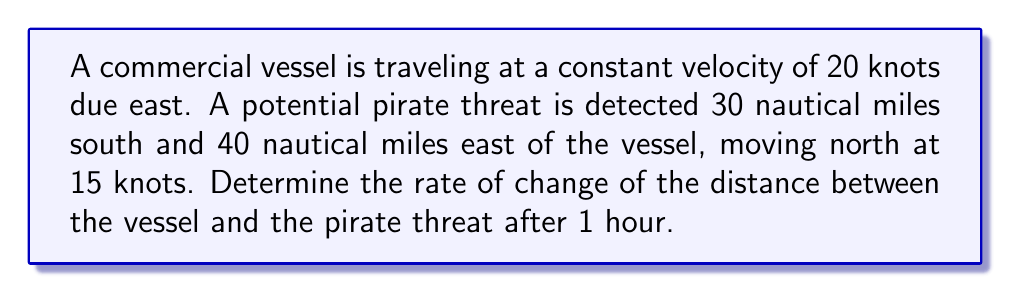Show me your answer to this math problem. Let's approach this step-by-step:

1) First, we need to set up a coordinate system. Let's place the origin at the initial position of the commercial vessel.

2) The vessel's position after time $t$ (in hours) is:
   $$(20t, 0)$$

3) The pirate's initial position is (40, -30). After time $t$, its position is:
   $$(40, -30 + 15t)$$

4) The distance $d$ between the two vessels at time $t$ is given by:
   $$d(t) = \sqrt{(40-20t)^2 + (-30+15t)^2}$$

5) To find the rate of change of distance, we need to differentiate $d(t)$ with respect to $t$:
   $$\frac{d}{dt}d(t) = \frac{1}{2}((40-20t)^2 + (-30+15t)^2)^{-1/2} \cdot \frac{d}{dt}((40-20t)^2 + (-30+15t)^2)$$

6) Simplifying:
   $$\frac{d}{dt}d(t) = \frac{-40(40-20t) + 30(-30+15t)}{\sqrt{(40-20t)^2 + (-30+15t)^2}}$$

7) We need to evaluate this at $t=1$:
   $$\frac{d}{dt}d(1) = \frac{-40(20) + 30(-15)}{\sqrt{20^2 + (-15)^2}} = \frac{-800-450}{\sqrt{400+225}} = \frac{-1250}{25} = -50$$

8) The negative value indicates that the distance is decreasing.
Answer: $-50$ knots 